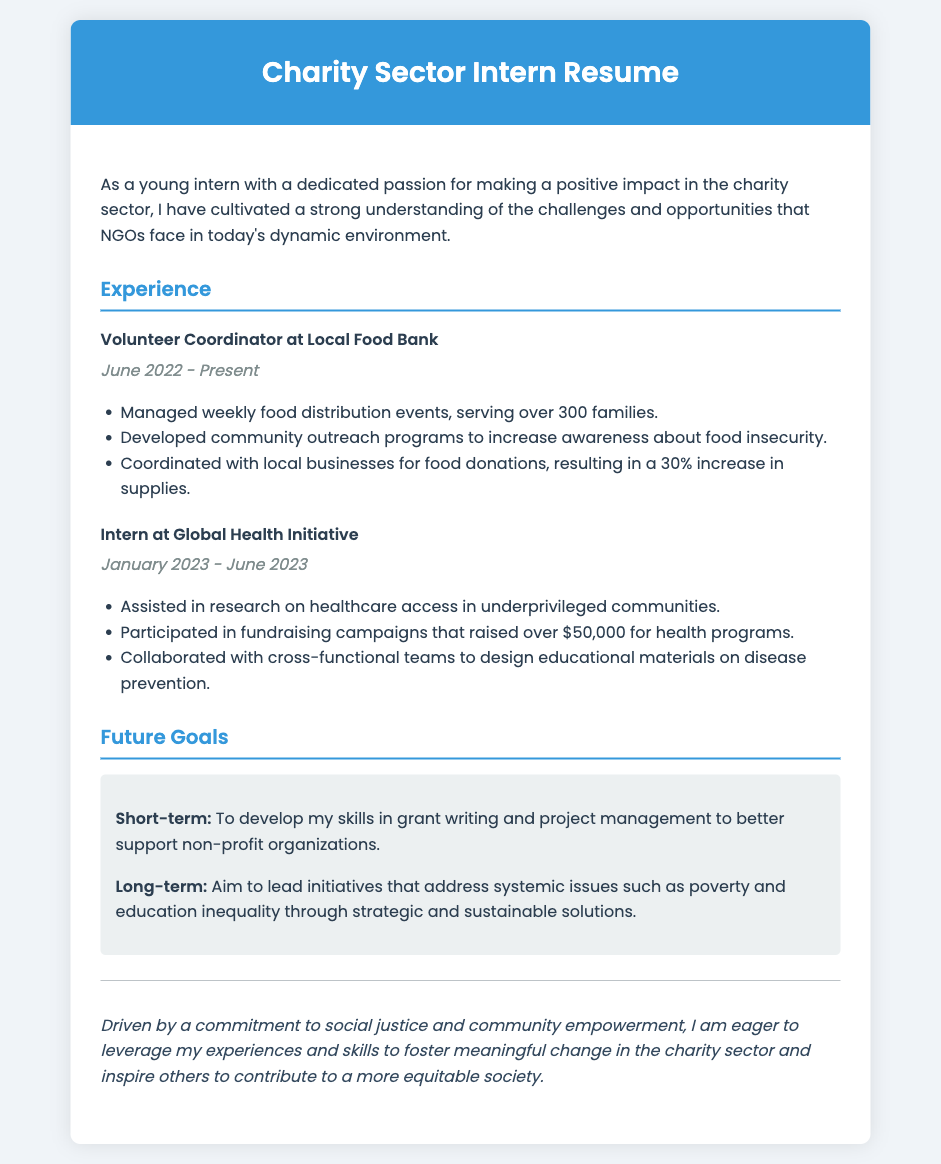what is the current position held? The position currently held is mentioned under Experience as Volunteer Coordinator at Local Food Bank.
Answer: Volunteer Coordinator when did the internship at Global Health Initiative start? The start date of the internship is explicitly stated in the document as January 2023.
Answer: January 2023 how many families were served during weekly food distribution events? The number of families served is provided in the document and is mentioned as over 300 families.
Answer: over 300 families what is the aim of the long-term goals? The long-term goals aim to lead initiatives that address systemic issues such as poverty and education inequality.
Answer: lead initiatives that address systemic issues how much money was raised during fundraising campaigns? The amount raised during the fundraising campaigns is clearly mentioned in the document as over $50,000.
Answer: over $50,000 what organization is associated with the role of Volunteer Coordinator? The organization where the role of Volunteer Coordinator is held is mentioned as Local Food Bank.
Answer: Local Food Bank what type of programs did the individual develop as a volunteer coordinator? The types of programs developed are specified in the document as community outreach programs.
Answer: community outreach programs what is the focus of the personal statement in the resume? The focus of the personal statement highlights a commitment to social justice and community empowerment.
Answer: social justice and community empowerment 